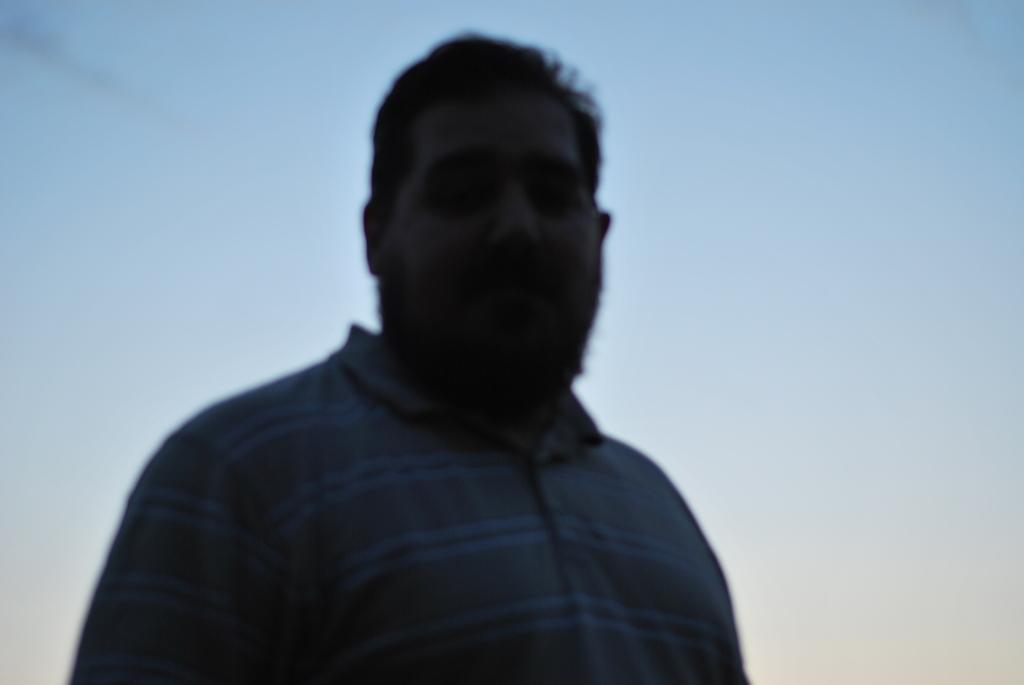How would you summarize this image in a sentence or two? This picture shows a man. He wore a t-shirt and we see a blue cloudy Sky. 